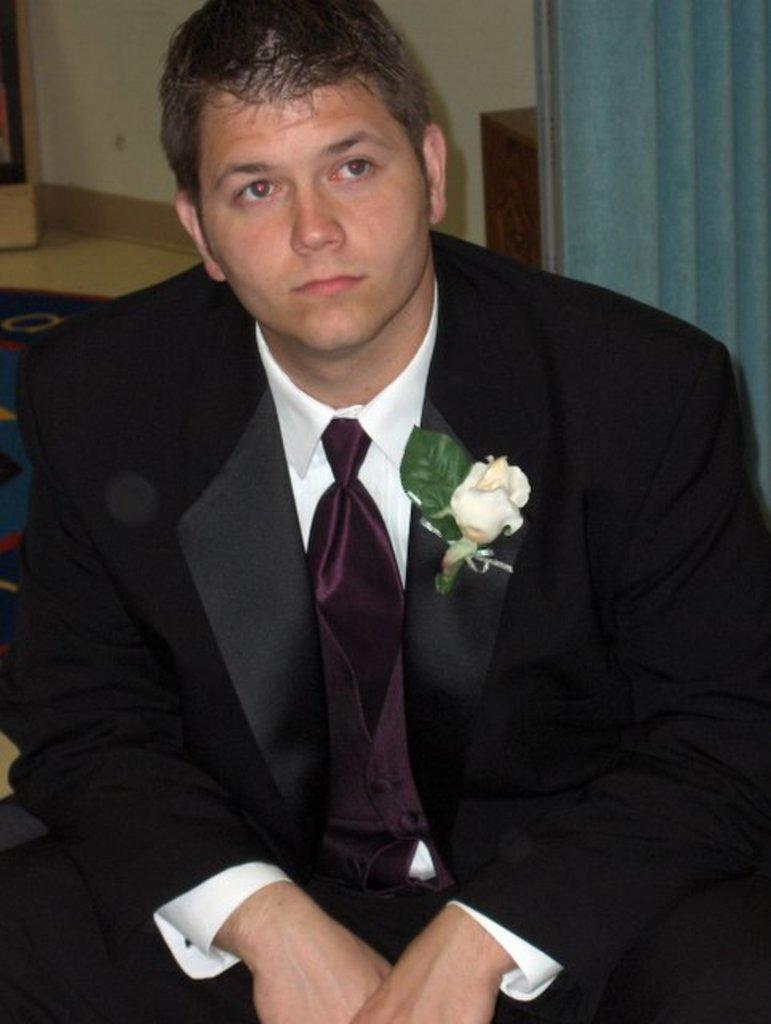What is the person in the image wearing? The person in the image is wearing a suit. What natural elements can be seen in the image? There is a flower and a leaf in the image. Where are the flower and leaf located in the image? The flower and leaf are on a court in the image. What can be seen in the background of the image? There is a wall, a floor, and a curtain in the background of the image. What is the person's opinion on the balloon in the image? There is no balloon present in the image, so it is not possible to determine the person's opinion on it. 